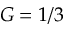<formula> <loc_0><loc_0><loc_500><loc_500>G = 1 / 3</formula> 